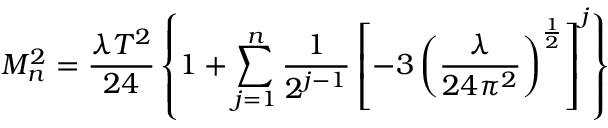<formula> <loc_0><loc_0><loc_500><loc_500>M _ { n } ^ { 2 } = \frac { \lambda T ^ { 2 } } { 2 4 } \left \{ 1 + \sum _ { j = 1 } ^ { n } \frac { 1 } { 2 ^ { j - 1 } } \left [ - 3 \left ( \frac { \lambda } { 2 4 \pi ^ { 2 } } \right ) ^ { \frac { 1 } { 2 } } \right ] ^ { j } \right \}</formula> 